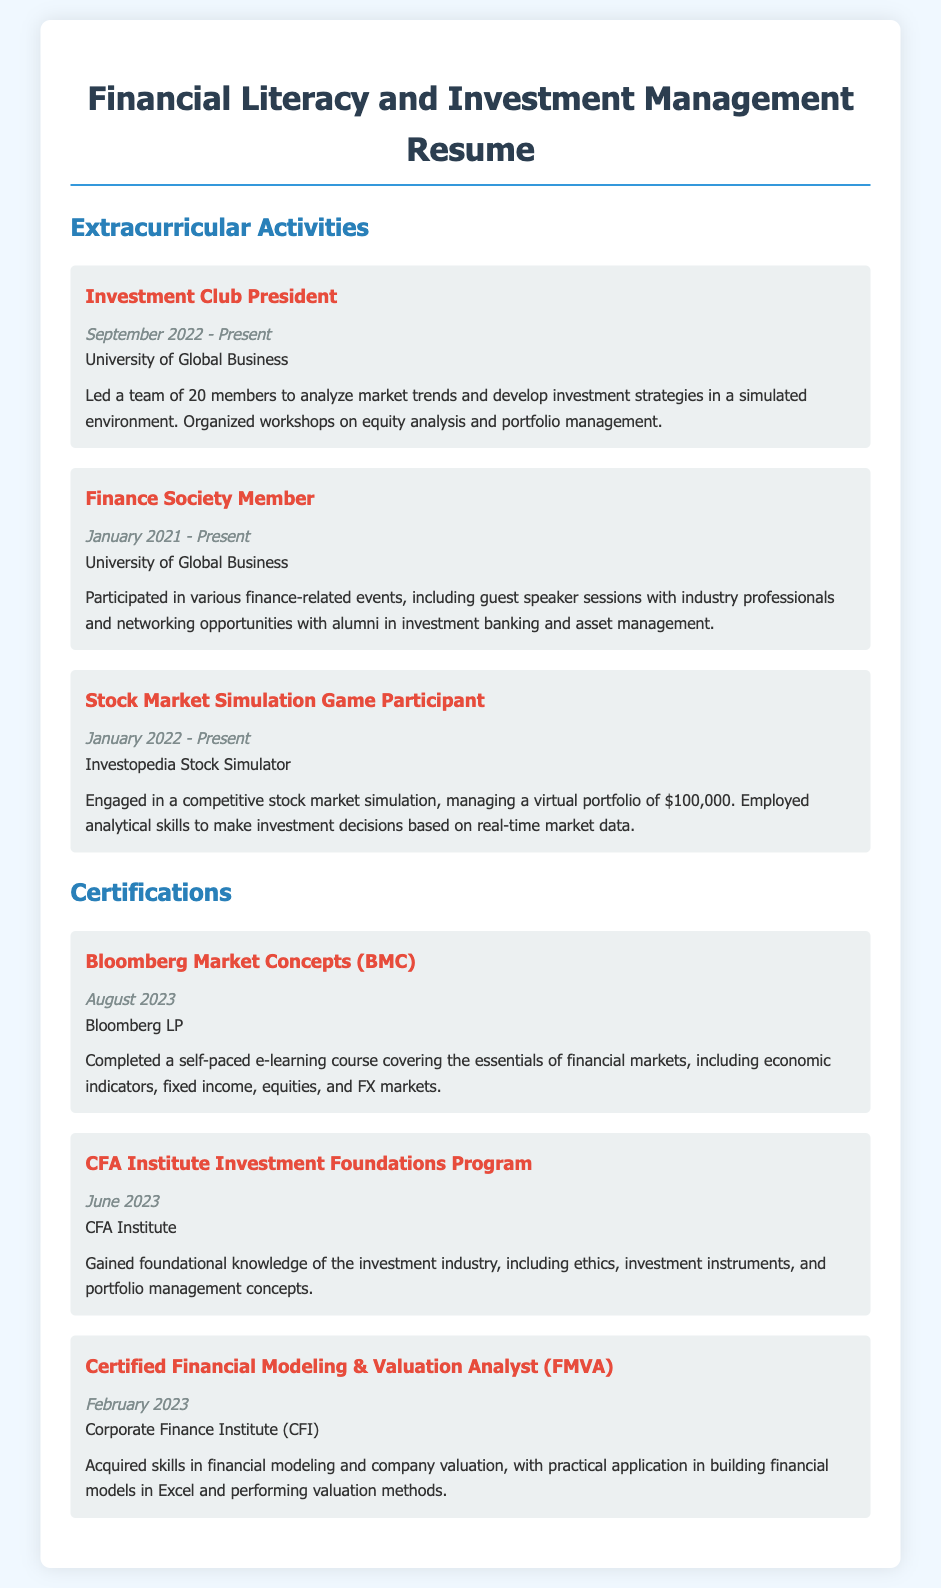what is the role of the extracurricular activity titled "Investment Club President"? The "Investment Club President" leads a team to analyze market trends and develop investment strategies.
Answer: leads a team when did the "CFA Institute Investment Foundations Program" certification get completed? The certification was completed in June 2023, as listed in the document.
Answer: June 2023 how many members are in the Investment Club? The document states that the Investment Club has a team of 20 members.
Answer: 20 members what is the virtual portfolio amount managed in the Stock Market Simulation Game? The document specifies that the participant manages a virtual portfolio of $100,000.
Answer: $100,000 what type of events does the Finance Society Member participate in? The member participates in finance-related events, including guest speaker sessions and networking opportunities.
Answer: events how long has the "Stock Market Simulation Game Participant" been active? The participant has been engaged in the simulation since January 2022 to the present, indicating it has been active for about 1.5 years.
Answer: since January 2022 which organization offers the Bloomberg Market Concepts certification? The document mentions that Bloomberg LP offers the Bloomberg Market Concepts certification.
Answer: Bloomberg LP what skillset is demonstrated by completing the Certified Financial Modeling & Valuation Analyst certification? The certification focuses on skills in financial modeling and company valuation.
Answer: financial modeling and company valuation what is the main focus of workshops organized by the Investment Club? The workshops focus on equity analysis and portfolio management, as stated in the description.
Answer: equity analysis and portfolio management 